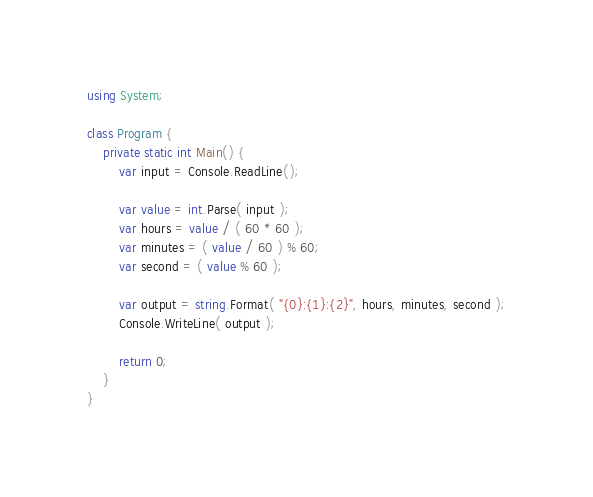<code> <loc_0><loc_0><loc_500><loc_500><_C#_>using System;

class Program {
    private static int Main() {
        var input = Console.ReadLine();

        var value = int.Parse( input );
        var hours = value / ( 60 * 60 );
        var minutes = ( value / 60 ) % 60;
        var second = ( value % 60 );

        var output = string.Format( "{0}:{1}:{2}", hours, minutes, second );
        Console.WriteLine( output );

        return 0;
    }
}</code> 